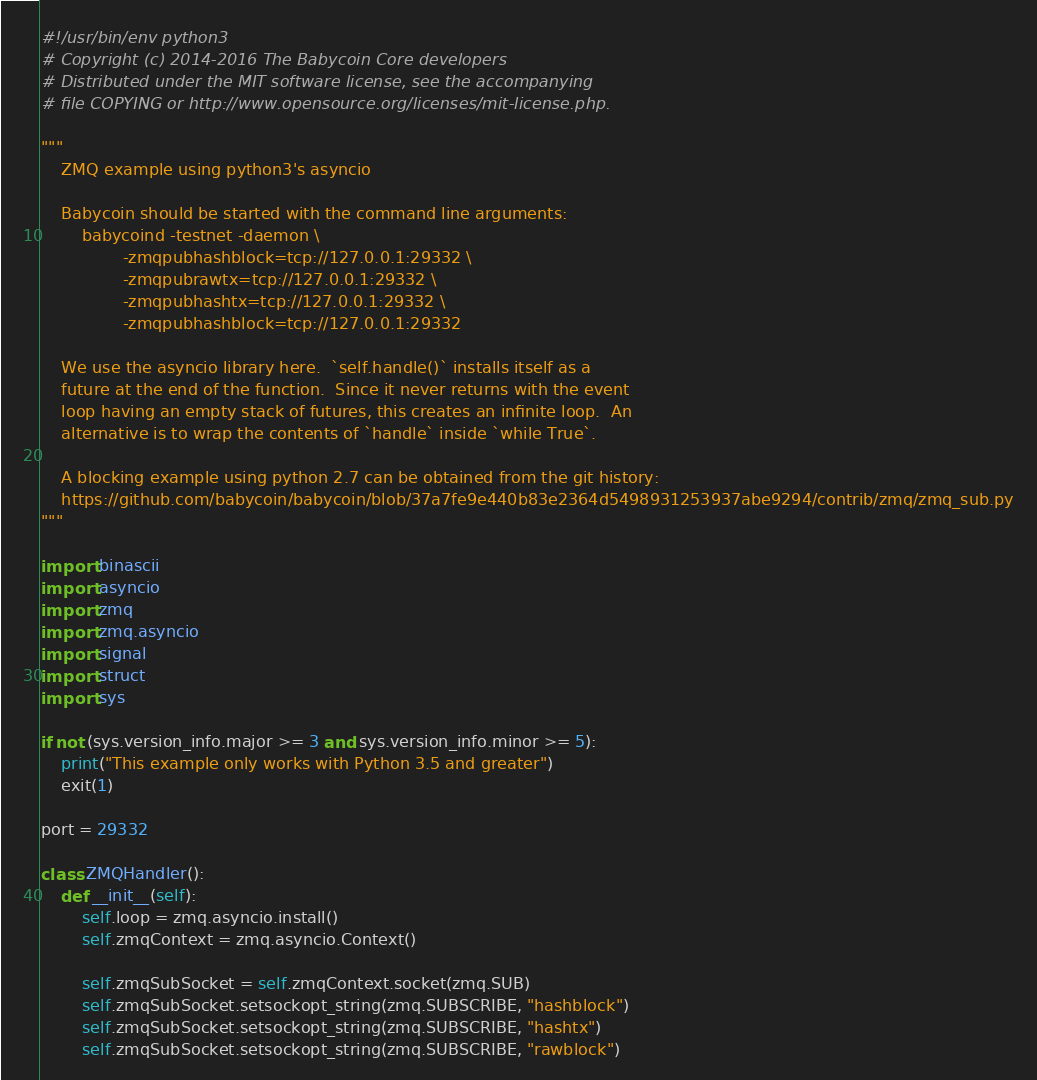Convert code to text. <code><loc_0><loc_0><loc_500><loc_500><_Python_>#!/usr/bin/env python3
# Copyright (c) 2014-2016 The Babycoin Core developers
# Distributed under the MIT software license, see the accompanying
# file COPYING or http://www.opensource.org/licenses/mit-license.php.

"""
    ZMQ example using python3's asyncio

    Babycoin should be started with the command line arguments:
        babycoind -testnet -daemon \
                -zmqpubhashblock=tcp://127.0.0.1:29332 \
                -zmqpubrawtx=tcp://127.0.0.1:29332 \
                -zmqpubhashtx=tcp://127.0.0.1:29332 \
                -zmqpubhashblock=tcp://127.0.0.1:29332

    We use the asyncio library here.  `self.handle()` installs itself as a
    future at the end of the function.  Since it never returns with the event
    loop having an empty stack of futures, this creates an infinite loop.  An
    alternative is to wrap the contents of `handle` inside `while True`.

    A blocking example using python 2.7 can be obtained from the git history:
    https://github.com/babycoin/babycoin/blob/37a7fe9e440b83e2364d5498931253937abe9294/contrib/zmq/zmq_sub.py
"""

import binascii
import asyncio
import zmq
import zmq.asyncio
import signal
import struct
import sys

if not (sys.version_info.major >= 3 and sys.version_info.minor >= 5):
    print("This example only works with Python 3.5 and greater")
    exit(1)

port = 29332

class ZMQHandler():
    def __init__(self):
        self.loop = zmq.asyncio.install()
        self.zmqContext = zmq.asyncio.Context()

        self.zmqSubSocket = self.zmqContext.socket(zmq.SUB)
        self.zmqSubSocket.setsockopt_string(zmq.SUBSCRIBE, "hashblock")
        self.zmqSubSocket.setsockopt_string(zmq.SUBSCRIBE, "hashtx")
        self.zmqSubSocket.setsockopt_string(zmq.SUBSCRIBE, "rawblock")</code> 